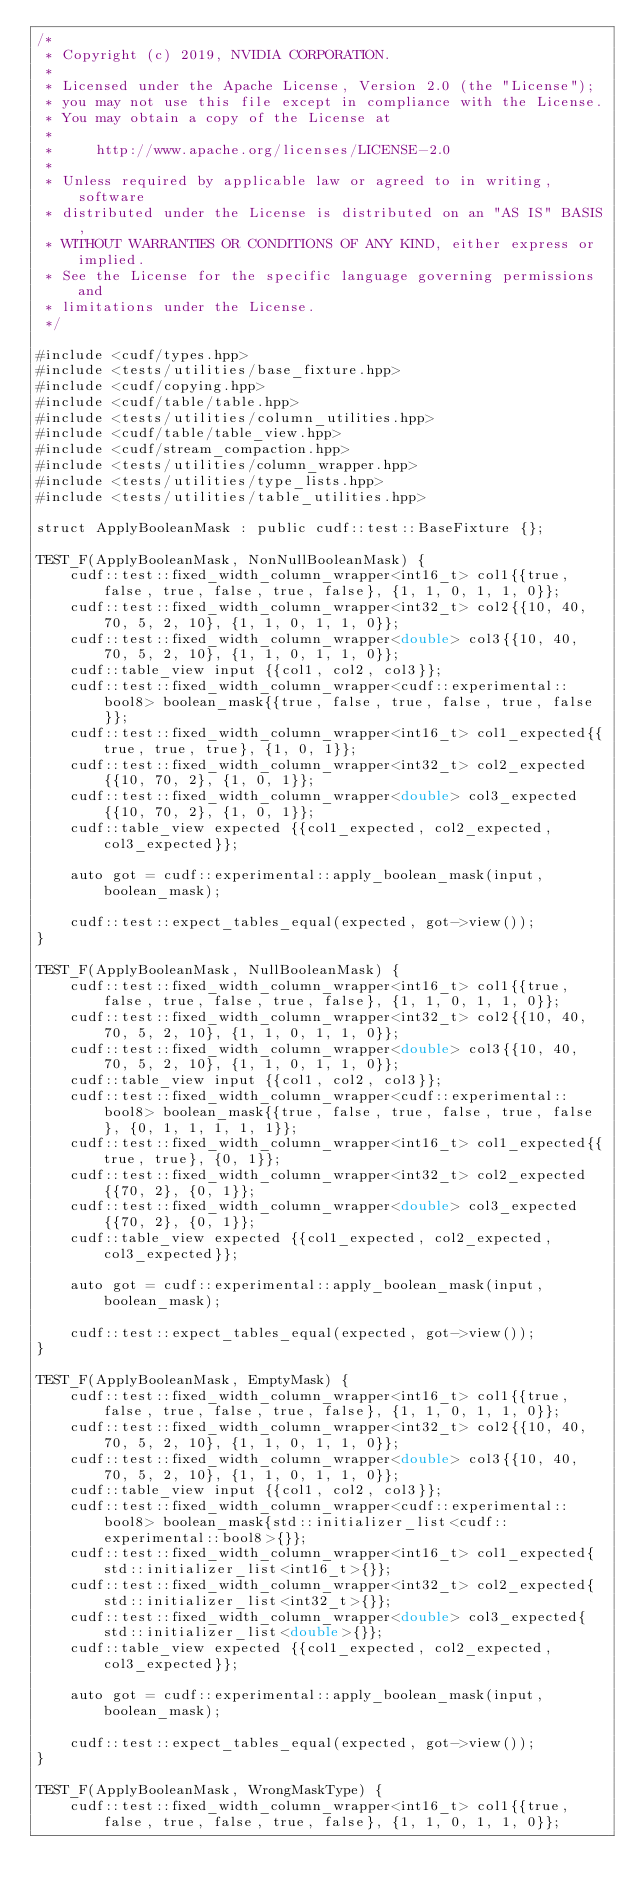<code> <loc_0><loc_0><loc_500><loc_500><_Cuda_>/*
 * Copyright (c) 2019, NVIDIA CORPORATION.
 *
 * Licensed under the Apache License, Version 2.0 (the "License");
 * you may not use this file except in compliance with the License.
 * You may obtain a copy of the License at
 *
 *     http://www.apache.org/licenses/LICENSE-2.0
 *
 * Unless required by applicable law or agreed to in writing, software
 * distributed under the License is distributed on an "AS IS" BASIS,
 * WITHOUT WARRANTIES OR CONDITIONS OF ANY KIND, either express or implied.
 * See the License for the specific language governing permissions and
 * limitations under the License.
 */

#include <cudf/types.hpp>
#include <tests/utilities/base_fixture.hpp>
#include <cudf/copying.hpp>
#include <cudf/table/table.hpp>
#include <tests/utilities/column_utilities.hpp>
#include <cudf/table/table_view.hpp>
#include <cudf/stream_compaction.hpp>
#include <tests/utilities/column_wrapper.hpp>
#include <tests/utilities/type_lists.hpp>
#include <tests/utilities/table_utilities.hpp>

struct ApplyBooleanMask : public cudf::test::BaseFixture {};

TEST_F(ApplyBooleanMask, NonNullBooleanMask) {
    cudf::test::fixed_width_column_wrapper<int16_t> col1{{true, false, true, false, true, false}, {1, 1, 0, 1, 1, 0}};
    cudf::test::fixed_width_column_wrapper<int32_t> col2{{10, 40, 70, 5, 2, 10}, {1, 1, 0, 1, 1, 0}};
    cudf::test::fixed_width_column_wrapper<double> col3{{10, 40, 70, 5, 2, 10}, {1, 1, 0, 1, 1, 0}};
    cudf::table_view input {{col1, col2, col3}};
    cudf::test::fixed_width_column_wrapper<cudf::experimental::bool8> boolean_mask{{true, false, true, false, true, false}};
    cudf::test::fixed_width_column_wrapper<int16_t> col1_expected{{true, true, true}, {1, 0, 1}};
    cudf::test::fixed_width_column_wrapper<int32_t> col2_expected{{10, 70, 2}, {1, 0, 1}};
    cudf::test::fixed_width_column_wrapper<double> col3_expected{{10, 70, 2}, {1, 0, 1}};
    cudf::table_view expected {{col1_expected, col2_expected, col3_expected}};

    auto got = cudf::experimental::apply_boolean_mask(input, boolean_mask);

    cudf::test::expect_tables_equal(expected, got->view());
}

TEST_F(ApplyBooleanMask, NullBooleanMask) {
    cudf::test::fixed_width_column_wrapper<int16_t> col1{{true, false, true, false, true, false}, {1, 1, 0, 1, 1, 0}};
    cudf::test::fixed_width_column_wrapper<int32_t> col2{{10, 40, 70, 5, 2, 10}, {1, 1, 0, 1, 1, 0}};
    cudf::test::fixed_width_column_wrapper<double> col3{{10, 40, 70, 5, 2, 10}, {1, 1, 0, 1, 1, 0}};
    cudf::table_view input {{col1, col2, col3}};
    cudf::test::fixed_width_column_wrapper<cudf::experimental::bool8> boolean_mask{{true, false, true, false, true, false}, {0, 1, 1, 1, 1, 1}};
    cudf::test::fixed_width_column_wrapper<int16_t> col1_expected{{true, true}, {0, 1}};
    cudf::test::fixed_width_column_wrapper<int32_t> col2_expected{{70, 2}, {0, 1}};
    cudf::test::fixed_width_column_wrapper<double> col3_expected{{70, 2}, {0, 1}};
    cudf::table_view expected {{col1_expected, col2_expected, col3_expected}};

    auto got = cudf::experimental::apply_boolean_mask(input, boolean_mask);

    cudf::test::expect_tables_equal(expected, got->view());
}

TEST_F(ApplyBooleanMask, EmptyMask) {
    cudf::test::fixed_width_column_wrapper<int16_t> col1{{true, false, true, false, true, false}, {1, 1, 0, 1, 1, 0}};
    cudf::test::fixed_width_column_wrapper<int32_t> col2{{10, 40, 70, 5, 2, 10}, {1, 1, 0, 1, 1, 0}};
    cudf::test::fixed_width_column_wrapper<double> col3{{10, 40, 70, 5, 2, 10}, {1, 1, 0, 1, 1, 0}};
    cudf::table_view input {{col1, col2, col3}};
    cudf::test::fixed_width_column_wrapper<cudf::experimental::bool8> boolean_mask{std::initializer_list<cudf::experimental::bool8>{}};
    cudf::test::fixed_width_column_wrapper<int16_t> col1_expected{std::initializer_list<int16_t>{}};
    cudf::test::fixed_width_column_wrapper<int32_t> col2_expected{std::initializer_list<int32_t>{}};
    cudf::test::fixed_width_column_wrapper<double> col3_expected{std::initializer_list<double>{}};
    cudf::table_view expected {{col1_expected, col2_expected, col3_expected}};

    auto got = cudf::experimental::apply_boolean_mask(input, boolean_mask);

    cudf::test::expect_tables_equal(expected, got->view());
}

TEST_F(ApplyBooleanMask, WrongMaskType) {
    cudf::test::fixed_width_column_wrapper<int16_t> col1{{true, false, true, false, true, false}, {1, 1, 0, 1, 1, 0}};</code> 